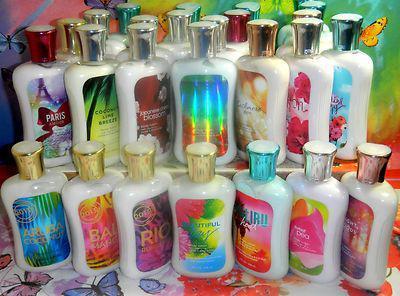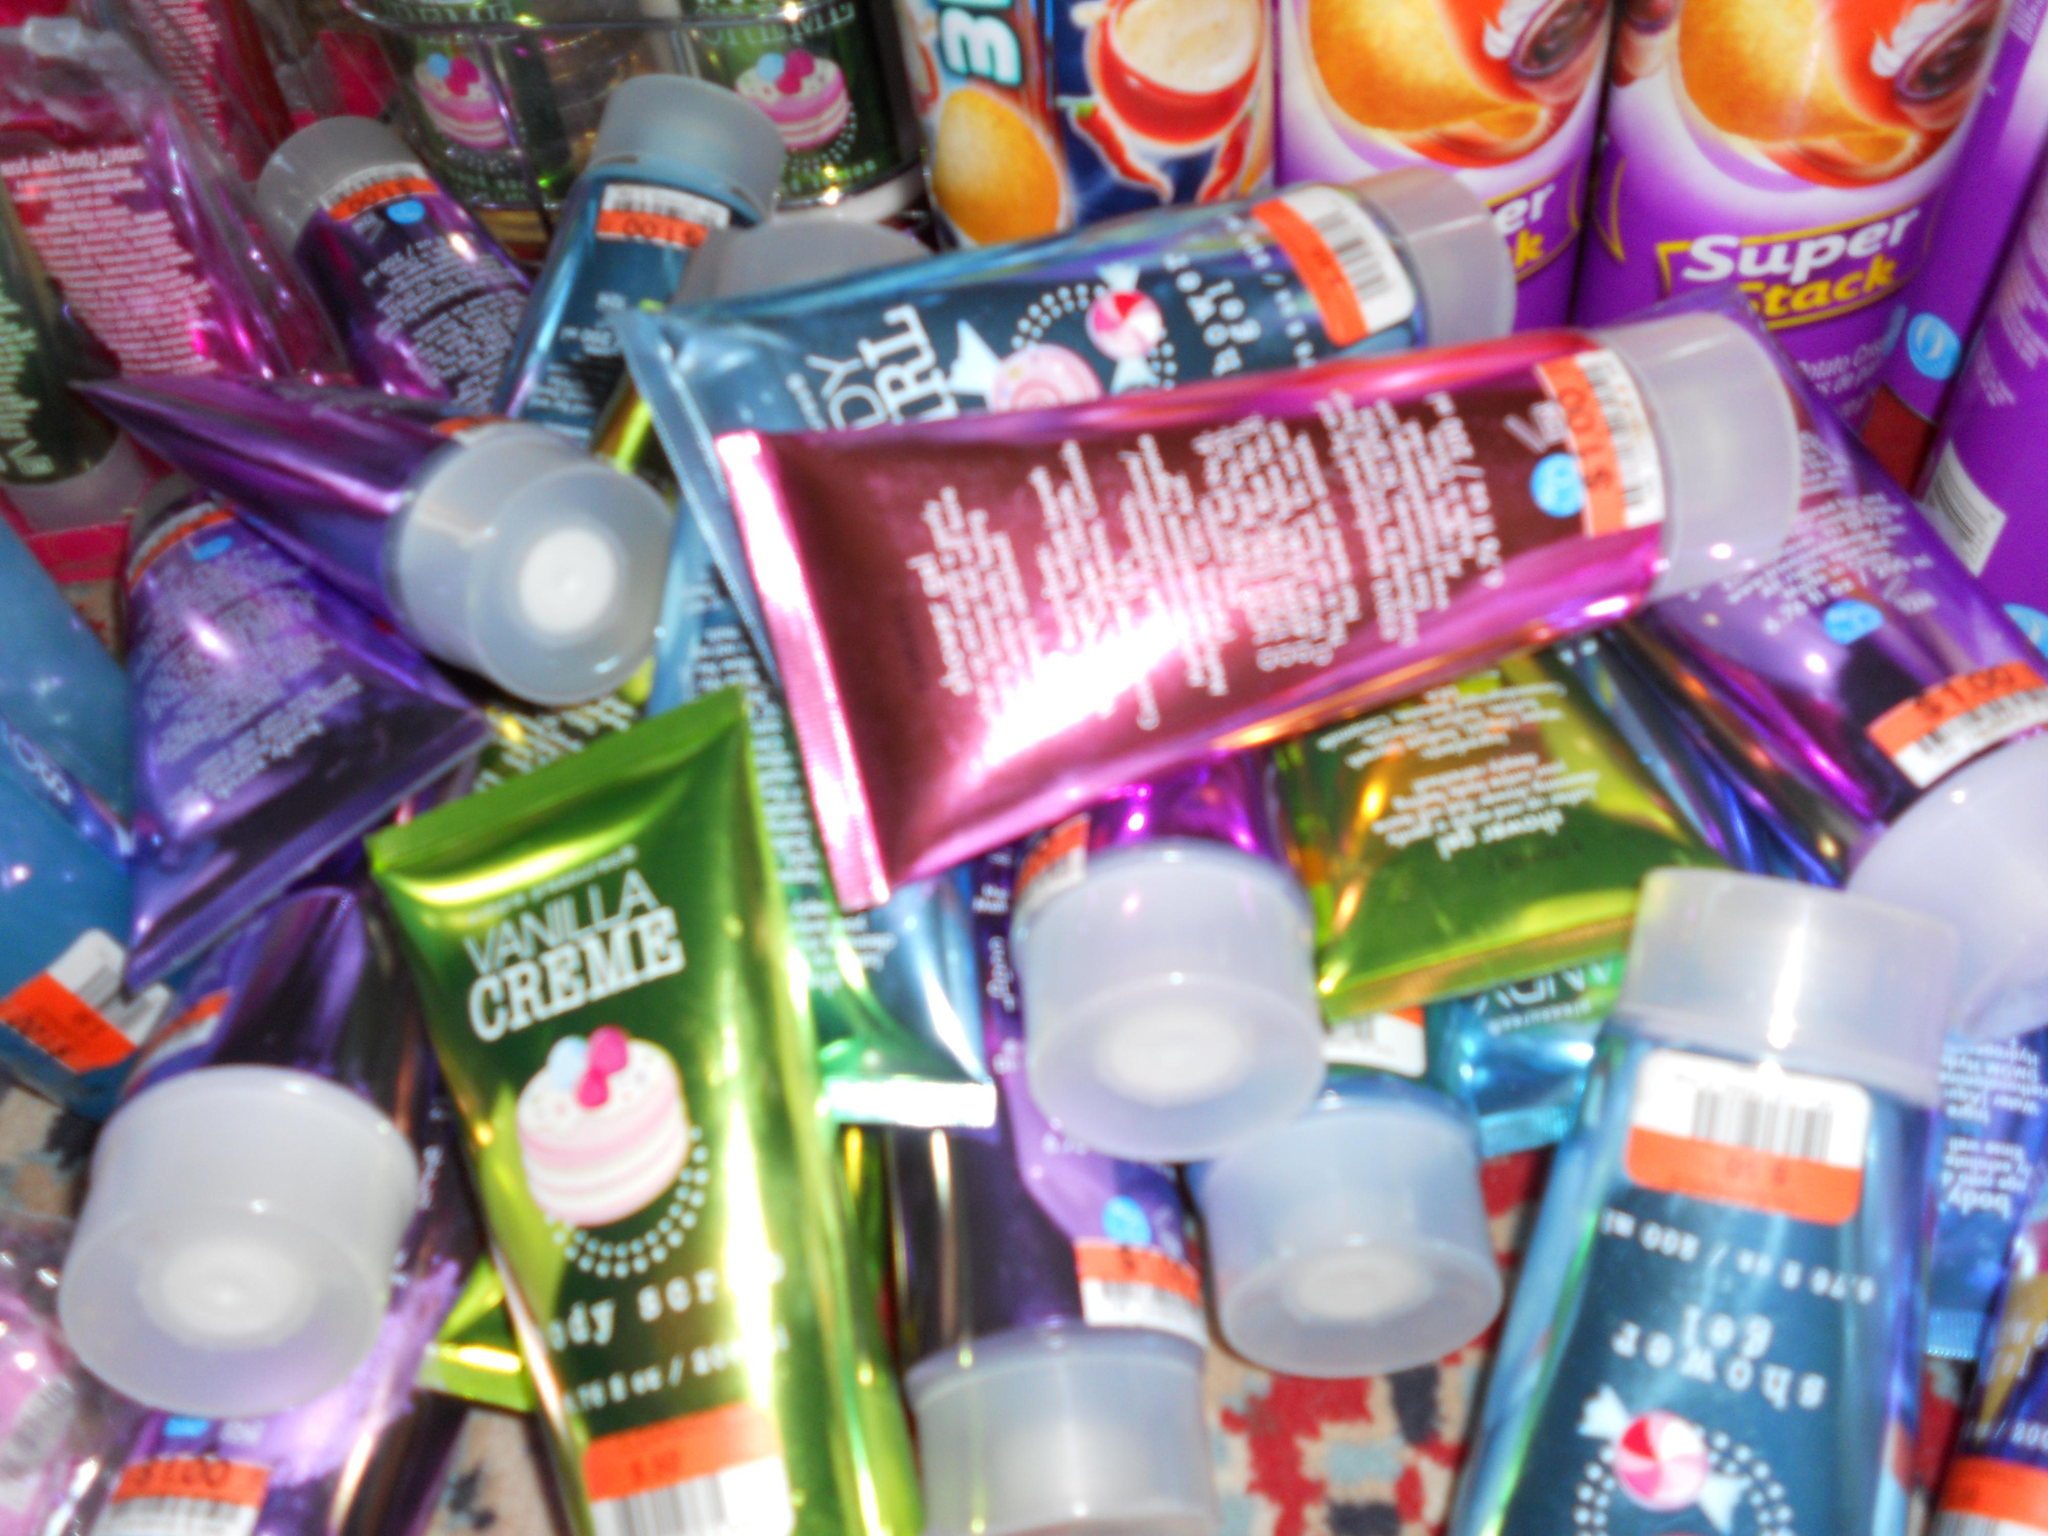The first image is the image on the left, the second image is the image on the right. Evaluate the accuracy of this statement regarding the images: "There are only two bottles in one of the images.". Is it true? Answer yes or no. No. 